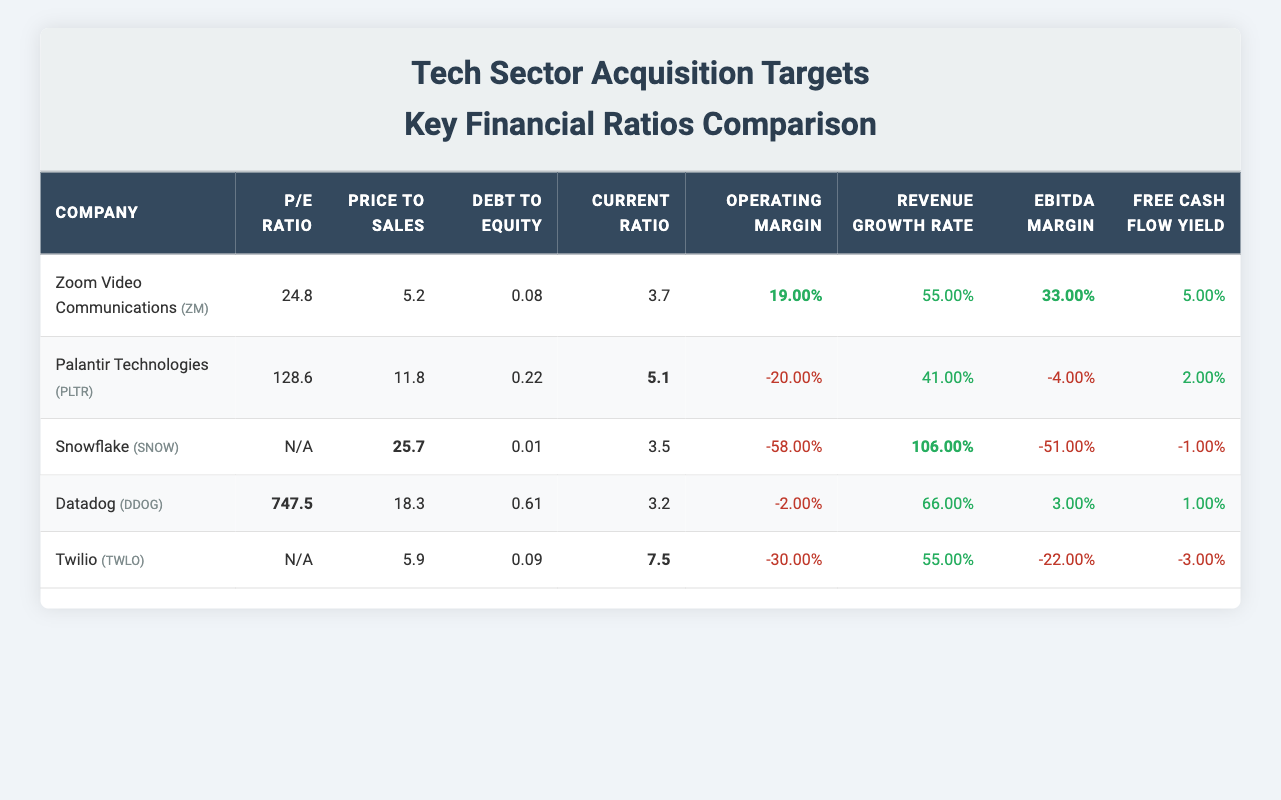What is the P/E ratio of Zoom Video Communications? The P/E ratio for Zoom Video Communications is directly listed in the table as 24.8.
Answer: 24.8 Which company has the highest price-to-sales ratio? By comparing the price-to-sales ratios in the table, Palantir Technologies has the highest value at 11.8.
Answer: Palantir Technologies What is the average current ratio of the companies listed? The current ratio values are 3.7, 5.1, 3.5, 3.2, and 7.5. Adding these gives a total of 23.0, and dividing by the number of companies (5) results in an average current ratio of 4.6.
Answer: 4.6 Does Datadog have a negative operating margin? The operating margin for Datadog is listed as -2.00%, which indicates it is negative.
Answer: Yes Which company has the best revenue growth rate? The revenue growth rates are 55.00% for Zoom, 41.00% for Palantir, 106.00% for Snowflake, 66.00% for Datadog, and 55.00% for Twilio. The highest rate is 106.00% for Snowflake.
Answer: Snowflake What is the debt-to-equity ratio of the company with the highest EBITDA margin? The EBITDA margins are 33.00% for Zoom, -4.00% for Palantir, -51.00% for Snowflake, 3.00% for Datadog, and -22.00% for Twilio. The highest is 33.00% for Zoom, which has a debt-to-equity ratio of 0.08.
Answer: 0.08 Is Twilio's free cash flow yield positive? The free cash flow yield for Twilio is -3.00%, confirming it is negative.
Answer: No Which two companies have the lowest debt-to-equity ratios? The debt-to-equity ratios are 0.08 for Zoom, 0.22 for Palantir, 0.01 for Snowflake, 0.61 for Datadog, and 0.09 for Twilio. The two lowest ratios are 0.01 and 0.08, corresponding to Snowflake and Zoom, respectively.
Answer: Snowflake and Zoom 